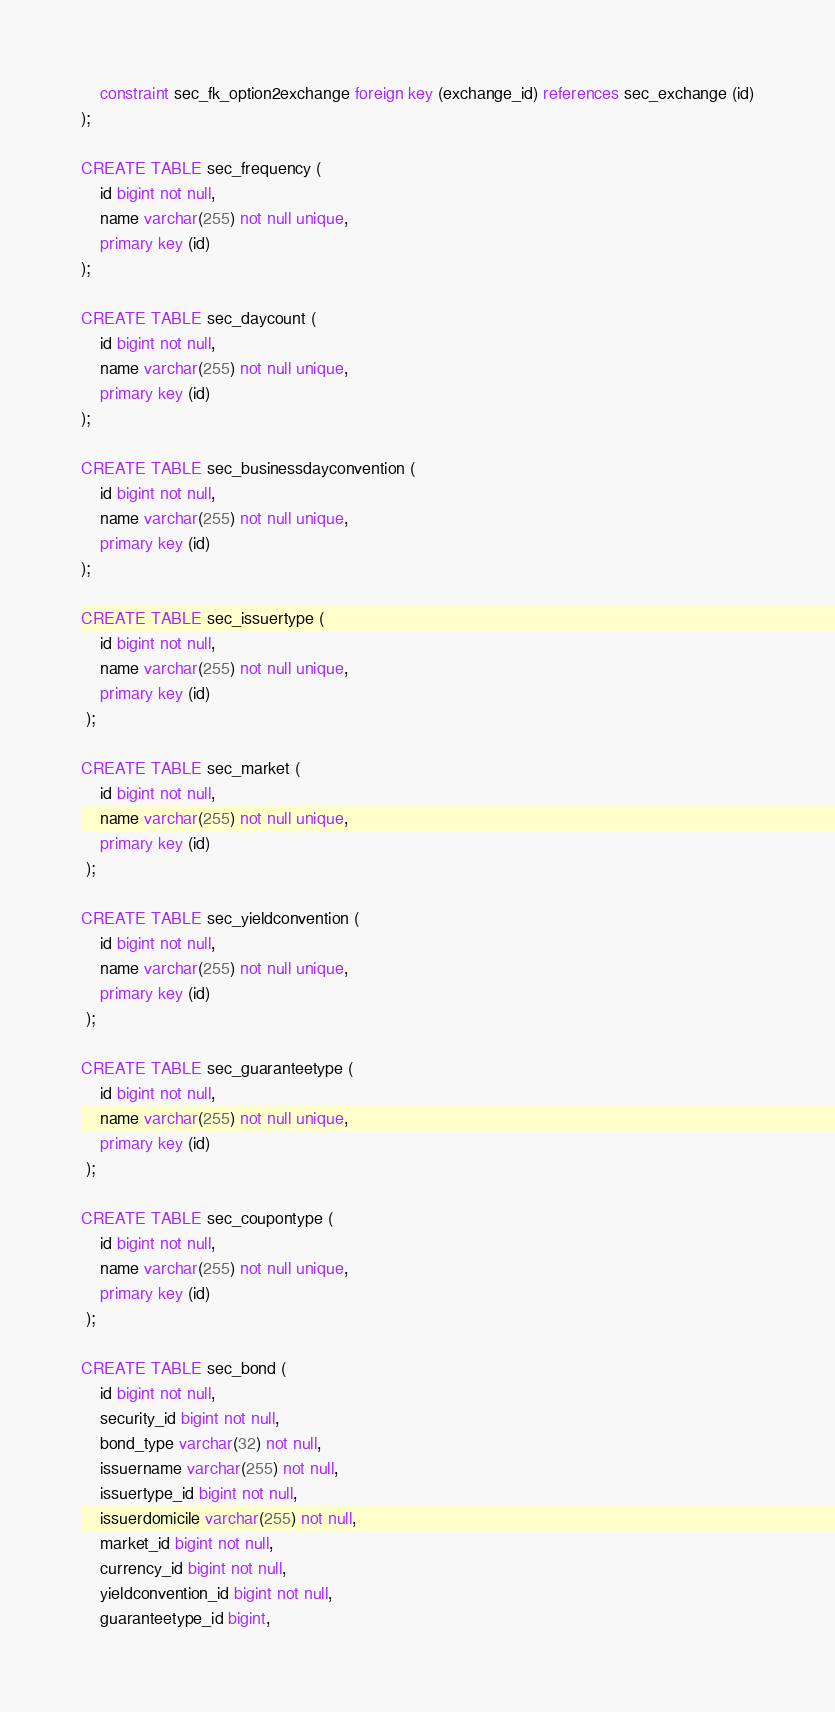Convert code to text. <code><loc_0><loc_0><loc_500><loc_500><_SQL_>    constraint sec_fk_option2exchange foreign key (exchange_id) references sec_exchange (id)
);

CREATE TABLE sec_frequency (
    id bigint not null,
    name varchar(255) not null unique,
    primary key (id)
);

CREATE TABLE sec_daycount (
    id bigint not null,
    name varchar(255) not null unique,
    primary key (id)
);

CREATE TABLE sec_businessdayconvention (
    id bigint not null,
    name varchar(255) not null unique,
    primary key (id)
);

CREATE TABLE sec_issuertype (
    id bigint not null,
    name varchar(255) not null unique,
    primary key (id)
 );

CREATE TABLE sec_market (
    id bigint not null,
    name varchar(255) not null unique,
    primary key (id)
 );

CREATE TABLE sec_yieldconvention (
    id bigint not null,
    name varchar(255) not null unique,
    primary key (id)
 );

CREATE TABLE sec_guaranteetype (
    id bigint not null,
    name varchar(255) not null unique,
    primary key (id)
 );

CREATE TABLE sec_coupontype (
    id bigint not null,
    name varchar(255) not null unique,
    primary key (id)
 );

CREATE TABLE sec_bond (
    id bigint not null,
    security_id bigint not null,
    bond_type varchar(32) not null,
    issuername varchar(255) not null,
    issuertype_id bigint not null,
    issuerdomicile varchar(255) not null,
    market_id bigint not null,
    currency_id bigint not null,
    yieldconvention_id bigint not null,
    guaranteetype_id bigint,</code> 